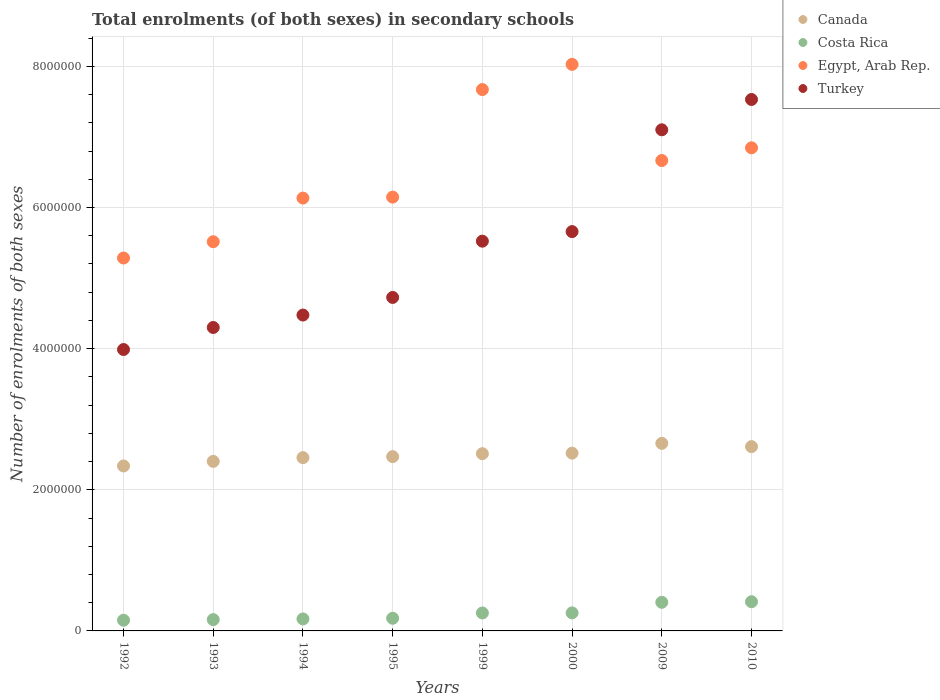How many different coloured dotlines are there?
Offer a terse response. 4. Is the number of dotlines equal to the number of legend labels?
Give a very brief answer. Yes. What is the number of enrolments in secondary schools in Costa Rica in 2000?
Provide a succinct answer. 2.56e+05. Across all years, what is the maximum number of enrolments in secondary schools in Canada?
Your response must be concise. 2.66e+06. Across all years, what is the minimum number of enrolments in secondary schools in Egypt, Arab Rep.?
Keep it short and to the point. 5.28e+06. What is the total number of enrolments in secondary schools in Costa Rica in the graph?
Offer a terse response. 1.99e+06. What is the difference between the number of enrolments in secondary schools in Canada in 1992 and that in 1994?
Give a very brief answer. -1.18e+05. What is the difference between the number of enrolments in secondary schools in Canada in 1992 and the number of enrolments in secondary schools in Egypt, Arab Rep. in 1994?
Give a very brief answer. -3.80e+06. What is the average number of enrolments in secondary schools in Costa Rica per year?
Provide a short and direct response. 2.49e+05. In the year 1999, what is the difference between the number of enrolments in secondary schools in Costa Rica and number of enrolments in secondary schools in Egypt, Arab Rep.?
Provide a succinct answer. -7.42e+06. What is the ratio of the number of enrolments in secondary schools in Egypt, Arab Rep. in 1993 to that in 1999?
Give a very brief answer. 0.72. Is the difference between the number of enrolments in secondary schools in Costa Rica in 1994 and 2000 greater than the difference between the number of enrolments in secondary schools in Egypt, Arab Rep. in 1994 and 2000?
Your response must be concise. Yes. What is the difference between the highest and the second highest number of enrolments in secondary schools in Turkey?
Make the answer very short. 4.30e+05. What is the difference between the highest and the lowest number of enrolments in secondary schools in Turkey?
Keep it short and to the point. 3.54e+06. In how many years, is the number of enrolments in secondary schools in Costa Rica greater than the average number of enrolments in secondary schools in Costa Rica taken over all years?
Ensure brevity in your answer.  4. Is it the case that in every year, the sum of the number of enrolments in secondary schools in Turkey and number of enrolments in secondary schools in Egypt, Arab Rep.  is greater than the number of enrolments in secondary schools in Costa Rica?
Offer a very short reply. Yes. Does the number of enrolments in secondary schools in Costa Rica monotonically increase over the years?
Provide a succinct answer. Yes. Is the number of enrolments in secondary schools in Canada strictly greater than the number of enrolments in secondary schools in Egypt, Arab Rep. over the years?
Give a very brief answer. No. Is the number of enrolments in secondary schools in Costa Rica strictly less than the number of enrolments in secondary schools in Turkey over the years?
Ensure brevity in your answer.  Yes. How many dotlines are there?
Your answer should be very brief. 4. Are the values on the major ticks of Y-axis written in scientific E-notation?
Ensure brevity in your answer.  No. Does the graph contain grids?
Give a very brief answer. Yes. Where does the legend appear in the graph?
Ensure brevity in your answer.  Top right. How many legend labels are there?
Provide a short and direct response. 4. What is the title of the graph?
Keep it short and to the point. Total enrolments (of both sexes) in secondary schools. What is the label or title of the Y-axis?
Your answer should be compact. Number of enrolments of both sexes. What is the Number of enrolments of both sexes in Canada in 1992?
Offer a very short reply. 2.34e+06. What is the Number of enrolments of both sexes of Costa Rica in 1992?
Give a very brief answer. 1.52e+05. What is the Number of enrolments of both sexes of Egypt, Arab Rep. in 1992?
Make the answer very short. 5.28e+06. What is the Number of enrolments of both sexes in Turkey in 1992?
Your response must be concise. 3.99e+06. What is the Number of enrolments of both sexes in Canada in 1993?
Make the answer very short. 2.40e+06. What is the Number of enrolments of both sexes in Costa Rica in 1993?
Make the answer very short. 1.60e+05. What is the Number of enrolments of both sexes of Egypt, Arab Rep. in 1993?
Give a very brief answer. 5.52e+06. What is the Number of enrolments of both sexes of Turkey in 1993?
Your response must be concise. 4.30e+06. What is the Number of enrolments of both sexes in Canada in 1994?
Provide a short and direct response. 2.46e+06. What is the Number of enrolments of both sexes of Costa Rica in 1994?
Make the answer very short. 1.70e+05. What is the Number of enrolments of both sexes of Egypt, Arab Rep. in 1994?
Offer a very short reply. 6.13e+06. What is the Number of enrolments of both sexes of Turkey in 1994?
Your answer should be compact. 4.48e+06. What is the Number of enrolments of both sexes in Canada in 1995?
Make the answer very short. 2.47e+06. What is the Number of enrolments of both sexes of Costa Rica in 1995?
Your answer should be compact. 1.79e+05. What is the Number of enrolments of both sexes of Egypt, Arab Rep. in 1995?
Provide a short and direct response. 6.15e+06. What is the Number of enrolments of both sexes of Turkey in 1995?
Offer a very short reply. 4.73e+06. What is the Number of enrolments of both sexes of Canada in 1999?
Provide a short and direct response. 2.51e+06. What is the Number of enrolments of both sexes in Costa Rica in 1999?
Provide a succinct answer. 2.55e+05. What is the Number of enrolments of both sexes in Egypt, Arab Rep. in 1999?
Your answer should be very brief. 7.67e+06. What is the Number of enrolments of both sexes in Turkey in 1999?
Provide a short and direct response. 5.52e+06. What is the Number of enrolments of both sexes in Canada in 2000?
Your answer should be compact. 2.52e+06. What is the Number of enrolments of both sexes of Costa Rica in 2000?
Offer a very short reply. 2.56e+05. What is the Number of enrolments of both sexes of Egypt, Arab Rep. in 2000?
Keep it short and to the point. 8.03e+06. What is the Number of enrolments of both sexes of Turkey in 2000?
Make the answer very short. 5.66e+06. What is the Number of enrolments of both sexes of Canada in 2009?
Your answer should be very brief. 2.66e+06. What is the Number of enrolments of both sexes in Costa Rica in 2009?
Offer a terse response. 4.06e+05. What is the Number of enrolments of both sexes of Egypt, Arab Rep. in 2009?
Keep it short and to the point. 6.67e+06. What is the Number of enrolments of both sexes in Turkey in 2009?
Provide a short and direct response. 7.10e+06. What is the Number of enrolments of both sexes in Canada in 2010?
Ensure brevity in your answer.  2.61e+06. What is the Number of enrolments of both sexes of Costa Rica in 2010?
Your answer should be very brief. 4.14e+05. What is the Number of enrolments of both sexes in Egypt, Arab Rep. in 2010?
Your response must be concise. 6.85e+06. What is the Number of enrolments of both sexes of Turkey in 2010?
Keep it short and to the point. 7.53e+06. Across all years, what is the maximum Number of enrolments of both sexes in Canada?
Ensure brevity in your answer.  2.66e+06. Across all years, what is the maximum Number of enrolments of both sexes of Costa Rica?
Your answer should be very brief. 4.14e+05. Across all years, what is the maximum Number of enrolments of both sexes of Egypt, Arab Rep.?
Offer a terse response. 8.03e+06. Across all years, what is the maximum Number of enrolments of both sexes of Turkey?
Provide a succinct answer. 7.53e+06. Across all years, what is the minimum Number of enrolments of both sexes in Canada?
Offer a very short reply. 2.34e+06. Across all years, what is the minimum Number of enrolments of both sexes in Costa Rica?
Offer a terse response. 1.52e+05. Across all years, what is the minimum Number of enrolments of both sexes of Egypt, Arab Rep.?
Offer a terse response. 5.28e+06. Across all years, what is the minimum Number of enrolments of both sexes in Turkey?
Offer a very short reply. 3.99e+06. What is the total Number of enrolments of both sexes in Canada in the graph?
Offer a terse response. 2.00e+07. What is the total Number of enrolments of both sexes of Costa Rica in the graph?
Your answer should be compact. 1.99e+06. What is the total Number of enrolments of both sexes in Egypt, Arab Rep. in the graph?
Make the answer very short. 5.23e+07. What is the total Number of enrolments of both sexes in Turkey in the graph?
Your answer should be compact. 4.33e+07. What is the difference between the Number of enrolments of both sexes of Canada in 1992 and that in 1993?
Make the answer very short. -6.50e+04. What is the difference between the Number of enrolments of both sexes of Costa Rica in 1992 and that in 1993?
Offer a terse response. -8778. What is the difference between the Number of enrolments of both sexes of Egypt, Arab Rep. in 1992 and that in 1993?
Provide a short and direct response. -2.31e+05. What is the difference between the Number of enrolments of both sexes in Turkey in 1992 and that in 1993?
Offer a terse response. -3.12e+05. What is the difference between the Number of enrolments of both sexes of Canada in 1992 and that in 1994?
Give a very brief answer. -1.18e+05. What is the difference between the Number of enrolments of both sexes of Costa Rica in 1992 and that in 1994?
Make the answer very short. -1.83e+04. What is the difference between the Number of enrolments of both sexes of Egypt, Arab Rep. in 1992 and that in 1994?
Give a very brief answer. -8.49e+05. What is the difference between the Number of enrolments of both sexes in Turkey in 1992 and that in 1994?
Provide a succinct answer. -4.89e+05. What is the difference between the Number of enrolments of both sexes in Canada in 1992 and that in 1995?
Your response must be concise. -1.32e+05. What is the difference between the Number of enrolments of both sexes in Costa Rica in 1992 and that in 1995?
Make the answer very short. -2.79e+04. What is the difference between the Number of enrolments of both sexes of Egypt, Arab Rep. in 1992 and that in 1995?
Ensure brevity in your answer.  -8.63e+05. What is the difference between the Number of enrolments of both sexes in Turkey in 1992 and that in 1995?
Your answer should be compact. -7.38e+05. What is the difference between the Number of enrolments of both sexes in Canada in 1992 and that in 1999?
Provide a short and direct response. -1.74e+05. What is the difference between the Number of enrolments of both sexes in Costa Rica in 1992 and that in 1999?
Your answer should be very brief. -1.03e+05. What is the difference between the Number of enrolments of both sexes of Egypt, Arab Rep. in 1992 and that in 1999?
Your response must be concise. -2.39e+06. What is the difference between the Number of enrolments of both sexes in Turkey in 1992 and that in 1999?
Your response must be concise. -1.54e+06. What is the difference between the Number of enrolments of both sexes in Canada in 1992 and that in 2000?
Offer a very short reply. -1.82e+05. What is the difference between the Number of enrolments of both sexes of Costa Rica in 1992 and that in 2000?
Your response must be concise. -1.04e+05. What is the difference between the Number of enrolments of both sexes of Egypt, Arab Rep. in 1992 and that in 2000?
Give a very brief answer. -2.74e+06. What is the difference between the Number of enrolments of both sexes of Turkey in 1992 and that in 2000?
Keep it short and to the point. -1.67e+06. What is the difference between the Number of enrolments of both sexes in Canada in 1992 and that in 2009?
Keep it short and to the point. -3.20e+05. What is the difference between the Number of enrolments of both sexes of Costa Rica in 1992 and that in 2009?
Your answer should be very brief. -2.54e+05. What is the difference between the Number of enrolments of both sexes in Egypt, Arab Rep. in 1992 and that in 2009?
Ensure brevity in your answer.  -1.38e+06. What is the difference between the Number of enrolments of both sexes of Turkey in 1992 and that in 2009?
Your answer should be compact. -3.11e+06. What is the difference between the Number of enrolments of both sexes of Canada in 1992 and that in 2010?
Make the answer very short. -2.74e+05. What is the difference between the Number of enrolments of both sexes in Costa Rica in 1992 and that in 2010?
Your answer should be very brief. -2.62e+05. What is the difference between the Number of enrolments of both sexes in Egypt, Arab Rep. in 1992 and that in 2010?
Keep it short and to the point. -1.56e+06. What is the difference between the Number of enrolments of both sexes in Turkey in 1992 and that in 2010?
Offer a very short reply. -3.54e+06. What is the difference between the Number of enrolments of both sexes in Canada in 1993 and that in 1994?
Your answer should be very brief. -5.29e+04. What is the difference between the Number of enrolments of both sexes in Costa Rica in 1993 and that in 1994?
Your answer should be compact. -9486. What is the difference between the Number of enrolments of both sexes in Egypt, Arab Rep. in 1993 and that in 1994?
Ensure brevity in your answer.  -6.18e+05. What is the difference between the Number of enrolments of both sexes in Turkey in 1993 and that in 1994?
Make the answer very short. -1.76e+05. What is the difference between the Number of enrolments of both sexes of Canada in 1993 and that in 1995?
Your response must be concise. -6.70e+04. What is the difference between the Number of enrolments of both sexes of Costa Rica in 1993 and that in 1995?
Keep it short and to the point. -1.91e+04. What is the difference between the Number of enrolments of both sexes in Egypt, Arab Rep. in 1993 and that in 1995?
Ensure brevity in your answer.  -6.32e+05. What is the difference between the Number of enrolments of both sexes in Turkey in 1993 and that in 1995?
Your answer should be very brief. -4.26e+05. What is the difference between the Number of enrolments of both sexes in Canada in 1993 and that in 1999?
Make the answer very short. -1.09e+05. What is the difference between the Number of enrolments of both sexes in Costa Rica in 1993 and that in 1999?
Your answer should be very brief. -9.43e+04. What is the difference between the Number of enrolments of both sexes of Egypt, Arab Rep. in 1993 and that in 1999?
Give a very brief answer. -2.16e+06. What is the difference between the Number of enrolments of both sexes in Turkey in 1993 and that in 1999?
Your response must be concise. -1.22e+06. What is the difference between the Number of enrolments of both sexes of Canada in 1993 and that in 2000?
Make the answer very short. -1.17e+05. What is the difference between the Number of enrolments of both sexes in Costa Rica in 1993 and that in 2000?
Ensure brevity in your answer.  -9.54e+04. What is the difference between the Number of enrolments of both sexes in Egypt, Arab Rep. in 1993 and that in 2000?
Your answer should be very brief. -2.51e+06. What is the difference between the Number of enrolments of both sexes in Turkey in 1993 and that in 2000?
Provide a succinct answer. -1.36e+06. What is the difference between the Number of enrolments of both sexes of Canada in 1993 and that in 2009?
Provide a succinct answer. -2.55e+05. What is the difference between the Number of enrolments of both sexes of Costa Rica in 1993 and that in 2009?
Offer a very short reply. -2.45e+05. What is the difference between the Number of enrolments of both sexes in Egypt, Arab Rep. in 1993 and that in 2009?
Your answer should be very brief. -1.15e+06. What is the difference between the Number of enrolments of both sexes of Turkey in 1993 and that in 2009?
Provide a short and direct response. -2.80e+06. What is the difference between the Number of enrolments of both sexes of Canada in 1993 and that in 2010?
Make the answer very short. -2.09e+05. What is the difference between the Number of enrolments of both sexes in Costa Rica in 1993 and that in 2010?
Make the answer very short. -2.53e+05. What is the difference between the Number of enrolments of both sexes in Egypt, Arab Rep. in 1993 and that in 2010?
Your response must be concise. -1.33e+06. What is the difference between the Number of enrolments of both sexes of Turkey in 1993 and that in 2010?
Offer a terse response. -3.23e+06. What is the difference between the Number of enrolments of both sexes in Canada in 1994 and that in 1995?
Your answer should be compact. -1.41e+04. What is the difference between the Number of enrolments of both sexes of Costa Rica in 1994 and that in 1995?
Ensure brevity in your answer.  -9663. What is the difference between the Number of enrolments of both sexes of Egypt, Arab Rep. in 1994 and that in 1995?
Your answer should be very brief. -1.40e+04. What is the difference between the Number of enrolments of both sexes in Turkey in 1994 and that in 1995?
Offer a terse response. -2.49e+05. What is the difference between the Number of enrolments of both sexes of Canada in 1994 and that in 1999?
Provide a short and direct response. -5.61e+04. What is the difference between the Number of enrolments of both sexes of Costa Rica in 1994 and that in 1999?
Ensure brevity in your answer.  -8.48e+04. What is the difference between the Number of enrolments of both sexes in Egypt, Arab Rep. in 1994 and that in 1999?
Offer a terse response. -1.54e+06. What is the difference between the Number of enrolments of both sexes of Turkey in 1994 and that in 1999?
Your answer should be very brief. -1.05e+06. What is the difference between the Number of enrolments of both sexes of Canada in 1994 and that in 2000?
Your answer should be compact. -6.37e+04. What is the difference between the Number of enrolments of both sexes in Costa Rica in 1994 and that in 2000?
Make the answer very short. -8.59e+04. What is the difference between the Number of enrolments of both sexes of Egypt, Arab Rep. in 1994 and that in 2000?
Your response must be concise. -1.89e+06. What is the difference between the Number of enrolments of both sexes of Turkey in 1994 and that in 2000?
Your answer should be very brief. -1.18e+06. What is the difference between the Number of enrolments of both sexes in Canada in 1994 and that in 2009?
Your answer should be compact. -2.03e+05. What is the difference between the Number of enrolments of both sexes of Costa Rica in 1994 and that in 2009?
Provide a succinct answer. -2.36e+05. What is the difference between the Number of enrolments of both sexes in Egypt, Arab Rep. in 1994 and that in 2009?
Keep it short and to the point. -5.32e+05. What is the difference between the Number of enrolments of both sexes of Turkey in 1994 and that in 2009?
Your answer should be very brief. -2.62e+06. What is the difference between the Number of enrolments of both sexes in Canada in 1994 and that in 2010?
Your response must be concise. -1.56e+05. What is the difference between the Number of enrolments of both sexes in Costa Rica in 1994 and that in 2010?
Your response must be concise. -2.44e+05. What is the difference between the Number of enrolments of both sexes of Egypt, Arab Rep. in 1994 and that in 2010?
Ensure brevity in your answer.  -7.12e+05. What is the difference between the Number of enrolments of both sexes in Turkey in 1994 and that in 2010?
Provide a succinct answer. -3.05e+06. What is the difference between the Number of enrolments of both sexes of Canada in 1995 and that in 1999?
Your answer should be compact. -4.20e+04. What is the difference between the Number of enrolments of both sexes in Costa Rica in 1995 and that in 1999?
Provide a succinct answer. -7.52e+04. What is the difference between the Number of enrolments of both sexes of Egypt, Arab Rep. in 1995 and that in 1999?
Your answer should be very brief. -1.52e+06. What is the difference between the Number of enrolments of both sexes in Turkey in 1995 and that in 1999?
Provide a short and direct response. -7.97e+05. What is the difference between the Number of enrolments of both sexes of Canada in 1995 and that in 2000?
Provide a short and direct response. -4.95e+04. What is the difference between the Number of enrolments of both sexes in Costa Rica in 1995 and that in 2000?
Provide a short and direct response. -7.62e+04. What is the difference between the Number of enrolments of both sexes of Egypt, Arab Rep. in 1995 and that in 2000?
Offer a terse response. -1.88e+06. What is the difference between the Number of enrolments of both sexes of Turkey in 1995 and that in 2000?
Offer a terse response. -9.33e+05. What is the difference between the Number of enrolments of both sexes of Canada in 1995 and that in 2009?
Your answer should be very brief. -1.88e+05. What is the difference between the Number of enrolments of both sexes in Costa Rica in 1995 and that in 2009?
Give a very brief answer. -2.26e+05. What is the difference between the Number of enrolments of both sexes of Egypt, Arab Rep. in 1995 and that in 2009?
Provide a short and direct response. -5.19e+05. What is the difference between the Number of enrolments of both sexes in Turkey in 1995 and that in 2009?
Your response must be concise. -2.38e+06. What is the difference between the Number of enrolments of both sexes of Canada in 1995 and that in 2010?
Offer a very short reply. -1.42e+05. What is the difference between the Number of enrolments of both sexes in Costa Rica in 1995 and that in 2010?
Your answer should be compact. -2.34e+05. What is the difference between the Number of enrolments of both sexes in Egypt, Arab Rep. in 1995 and that in 2010?
Offer a very short reply. -6.98e+05. What is the difference between the Number of enrolments of both sexes in Turkey in 1995 and that in 2010?
Offer a very short reply. -2.81e+06. What is the difference between the Number of enrolments of both sexes of Canada in 1999 and that in 2000?
Your answer should be very brief. -7563. What is the difference between the Number of enrolments of both sexes in Costa Rica in 1999 and that in 2000?
Give a very brief answer. -1046. What is the difference between the Number of enrolments of both sexes of Egypt, Arab Rep. in 1999 and that in 2000?
Your response must be concise. -3.57e+05. What is the difference between the Number of enrolments of both sexes of Turkey in 1999 and that in 2000?
Your answer should be very brief. -1.35e+05. What is the difference between the Number of enrolments of both sexes of Canada in 1999 and that in 2009?
Make the answer very short. -1.46e+05. What is the difference between the Number of enrolments of both sexes in Costa Rica in 1999 and that in 2009?
Keep it short and to the point. -1.51e+05. What is the difference between the Number of enrolments of both sexes of Egypt, Arab Rep. in 1999 and that in 2009?
Your answer should be very brief. 1.01e+06. What is the difference between the Number of enrolments of both sexes of Turkey in 1999 and that in 2009?
Keep it short and to the point. -1.58e+06. What is the difference between the Number of enrolments of both sexes of Canada in 1999 and that in 2010?
Offer a terse response. -1.00e+05. What is the difference between the Number of enrolments of both sexes of Costa Rica in 1999 and that in 2010?
Ensure brevity in your answer.  -1.59e+05. What is the difference between the Number of enrolments of both sexes in Egypt, Arab Rep. in 1999 and that in 2010?
Ensure brevity in your answer.  8.25e+05. What is the difference between the Number of enrolments of both sexes of Turkey in 1999 and that in 2010?
Provide a short and direct response. -2.01e+06. What is the difference between the Number of enrolments of both sexes of Canada in 2000 and that in 2009?
Offer a very short reply. -1.39e+05. What is the difference between the Number of enrolments of both sexes in Costa Rica in 2000 and that in 2009?
Give a very brief answer. -1.50e+05. What is the difference between the Number of enrolments of both sexes of Egypt, Arab Rep. in 2000 and that in 2009?
Your answer should be compact. 1.36e+06. What is the difference between the Number of enrolments of both sexes of Turkey in 2000 and that in 2009?
Keep it short and to the point. -1.44e+06. What is the difference between the Number of enrolments of both sexes of Canada in 2000 and that in 2010?
Your answer should be compact. -9.25e+04. What is the difference between the Number of enrolments of both sexes of Costa Rica in 2000 and that in 2010?
Make the answer very short. -1.58e+05. What is the difference between the Number of enrolments of both sexes in Egypt, Arab Rep. in 2000 and that in 2010?
Offer a terse response. 1.18e+06. What is the difference between the Number of enrolments of both sexes of Turkey in 2000 and that in 2010?
Your response must be concise. -1.87e+06. What is the difference between the Number of enrolments of both sexes in Canada in 2009 and that in 2010?
Your answer should be very brief. 4.63e+04. What is the difference between the Number of enrolments of both sexes of Costa Rica in 2009 and that in 2010?
Ensure brevity in your answer.  -8102. What is the difference between the Number of enrolments of both sexes of Egypt, Arab Rep. in 2009 and that in 2010?
Provide a short and direct response. -1.80e+05. What is the difference between the Number of enrolments of both sexes in Turkey in 2009 and that in 2010?
Offer a terse response. -4.30e+05. What is the difference between the Number of enrolments of both sexes of Canada in 1992 and the Number of enrolments of both sexes of Costa Rica in 1993?
Ensure brevity in your answer.  2.18e+06. What is the difference between the Number of enrolments of both sexes of Canada in 1992 and the Number of enrolments of both sexes of Egypt, Arab Rep. in 1993?
Provide a succinct answer. -3.18e+06. What is the difference between the Number of enrolments of both sexes of Canada in 1992 and the Number of enrolments of both sexes of Turkey in 1993?
Give a very brief answer. -1.96e+06. What is the difference between the Number of enrolments of both sexes of Costa Rica in 1992 and the Number of enrolments of both sexes of Egypt, Arab Rep. in 1993?
Offer a terse response. -5.36e+06. What is the difference between the Number of enrolments of both sexes in Costa Rica in 1992 and the Number of enrolments of both sexes in Turkey in 1993?
Keep it short and to the point. -4.15e+06. What is the difference between the Number of enrolments of both sexes in Egypt, Arab Rep. in 1992 and the Number of enrolments of both sexes in Turkey in 1993?
Your answer should be compact. 9.84e+05. What is the difference between the Number of enrolments of both sexes of Canada in 1992 and the Number of enrolments of both sexes of Costa Rica in 1994?
Your answer should be very brief. 2.17e+06. What is the difference between the Number of enrolments of both sexes in Canada in 1992 and the Number of enrolments of both sexes in Egypt, Arab Rep. in 1994?
Your answer should be compact. -3.80e+06. What is the difference between the Number of enrolments of both sexes in Canada in 1992 and the Number of enrolments of both sexes in Turkey in 1994?
Provide a short and direct response. -2.14e+06. What is the difference between the Number of enrolments of both sexes of Costa Rica in 1992 and the Number of enrolments of both sexes of Egypt, Arab Rep. in 1994?
Provide a short and direct response. -5.98e+06. What is the difference between the Number of enrolments of both sexes of Costa Rica in 1992 and the Number of enrolments of both sexes of Turkey in 1994?
Offer a very short reply. -4.32e+06. What is the difference between the Number of enrolments of both sexes in Egypt, Arab Rep. in 1992 and the Number of enrolments of both sexes in Turkey in 1994?
Offer a very short reply. 8.08e+05. What is the difference between the Number of enrolments of both sexes in Canada in 1992 and the Number of enrolments of both sexes in Costa Rica in 1995?
Your answer should be compact. 2.16e+06. What is the difference between the Number of enrolments of both sexes of Canada in 1992 and the Number of enrolments of both sexes of Egypt, Arab Rep. in 1995?
Provide a short and direct response. -3.81e+06. What is the difference between the Number of enrolments of both sexes in Canada in 1992 and the Number of enrolments of both sexes in Turkey in 1995?
Your answer should be very brief. -2.39e+06. What is the difference between the Number of enrolments of both sexes of Costa Rica in 1992 and the Number of enrolments of both sexes of Egypt, Arab Rep. in 1995?
Offer a very short reply. -6.00e+06. What is the difference between the Number of enrolments of both sexes of Costa Rica in 1992 and the Number of enrolments of both sexes of Turkey in 1995?
Provide a succinct answer. -4.57e+06. What is the difference between the Number of enrolments of both sexes in Egypt, Arab Rep. in 1992 and the Number of enrolments of both sexes in Turkey in 1995?
Offer a terse response. 5.59e+05. What is the difference between the Number of enrolments of both sexes of Canada in 1992 and the Number of enrolments of both sexes of Costa Rica in 1999?
Provide a short and direct response. 2.08e+06. What is the difference between the Number of enrolments of both sexes in Canada in 1992 and the Number of enrolments of both sexes in Egypt, Arab Rep. in 1999?
Ensure brevity in your answer.  -5.33e+06. What is the difference between the Number of enrolments of both sexes in Canada in 1992 and the Number of enrolments of both sexes in Turkey in 1999?
Keep it short and to the point. -3.19e+06. What is the difference between the Number of enrolments of both sexes in Costa Rica in 1992 and the Number of enrolments of both sexes in Egypt, Arab Rep. in 1999?
Your answer should be very brief. -7.52e+06. What is the difference between the Number of enrolments of both sexes of Costa Rica in 1992 and the Number of enrolments of both sexes of Turkey in 1999?
Keep it short and to the point. -5.37e+06. What is the difference between the Number of enrolments of both sexes in Egypt, Arab Rep. in 1992 and the Number of enrolments of both sexes in Turkey in 1999?
Your answer should be very brief. -2.39e+05. What is the difference between the Number of enrolments of both sexes of Canada in 1992 and the Number of enrolments of both sexes of Costa Rica in 2000?
Your answer should be compact. 2.08e+06. What is the difference between the Number of enrolments of both sexes of Canada in 1992 and the Number of enrolments of both sexes of Egypt, Arab Rep. in 2000?
Keep it short and to the point. -5.69e+06. What is the difference between the Number of enrolments of both sexes in Canada in 1992 and the Number of enrolments of both sexes in Turkey in 2000?
Ensure brevity in your answer.  -3.32e+06. What is the difference between the Number of enrolments of both sexes of Costa Rica in 1992 and the Number of enrolments of both sexes of Egypt, Arab Rep. in 2000?
Make the answer very short. -7.88e+06. What is the difference between the Number of enrolments of both sexes in Costa Rica in 1992 and the Number of enrolments of both sexes in Turkey in 2000?
Make the answer very short. -5.51e+06. What is the difference between the Number of enrolments of both sexes in Egypt, Arab Rep. in 1992 and the Number of enrolments of both sexes in Turkey in 2000?
Your answer should be compact. -3.74e+05. What is the difference between the Number of enrolments of both sexes in Canada in 1992 and the Number of enrolments of both sexes in Costa Rica in 2009?
Offer a terse response. 1.93e+06. What is the difference between the Number of enrolments of both sexes in Canada in 1992 and the Number of enrolments of both sexes in Egypt, Arab Rep. in 2009?
Your answer should be very brief. -4.33e+06. What is the difference between the Number of enrolments of both sexes in Canada in 1992 and the Number of enrolments of both sexes in Turkey in 2009?
Provide a short and direct response. -4.76e+06. What is the difference between the Number of enrolments of both sexes in Costa Rica in 1992 and the Number of enrolments of both sexes in Egypt, Arab Rep. in 2009?
Keep it short and to the point. -6.51e+06. What is the difference between the Number of enrolments of both sexes in Costa Rica in 1992 and the Number of enrolments of both sexes in Turkey in 2009?
Make the answer very short. -6.95e+06. What is the difference between the Number of enrolments of both sexes of Egypt, Arab Rep. in 1992 and the Number of enrolments of both sexes of Turkey in 2009?
Ensure brevity in your answer.  -1.82e+06. What is the difference between the Number of enrolments of both sexes of Canada in 1992 and the Number of enrolments of both sexes of Costa Rica in 2010?
Provide a succinct answer. 1.92e+06. What is the difference between the Number of enrolments of both sexes in Canada in 1992 and the Number of enrolments of both sexes in Egypt, Arab Rep. in 2010?
Offer a very short reply. -4.51e+06. What is the difference between the Number of enrolments of both sexes of Canada in 1992 and the Number of enrolments of both sexes of Turkey in 2010?
Your response must be concise. -5.19e+06. What is the difference between the Number of enrolments of both sexes of Costa Rica in 1992 and the Number of enrolments of both sexes of Egypt, Arab Rep. in 2010?
Offer a very short reply. -6.69e+06. What is the difference between the Number of enrolments of both sexes of Costa Rica in 1992 and the Number of enrolments of both sexes of Turkey in 2010?
Offer a very short reply. -7.38e+06. What is the difference between the Number of enrolments of both sexes in Egypt, Arab Rep. in 1992 and the Number of enrolments of both sexes in Turkey in 2010?
Provide a succinct answer. -2.25e+06. What is the difference between the Number of enrolments of both sexes in Canada in 1993 and the Number of enrolments of both sexes in Costa Rica in 1994?
Offer a very short reply. 2.23e+06. What is the difference between the Number of enrolments of both sexes in Canada in 1993 and the Number of enrolments of both sexes in Egypt, Arab Rep. in 1994?
Make the answer very short. -3.73e+06. What is the difference between the Number of enrolments of both sexes of Canada in 1993 and the Number of enrolments of both sexes of Turkey in 1994?
Offer a very short reply. -2.07e+06. What is the difference between the Number of enrolments of both sexes of Costa Rica in 1993 and the Number of enrolments of both sexes of Egypt, Arab Rep. in 1994?
Ensure brevity in your answer.  -5.97e+06. What is the difference between the Number of enrolments of both sexes in Costa Rica in 1993 and the Number of enrolments of both sexes in Turkey in 1994?
Your response must be concise. -4.32e+06. What is the difference between the Number of enrolments of both sexes of Egypt, Arab Rep. in 1993 and the Number of enrolments of both sexes of Turkey in 1994?
Make the answer very short. 1.04e+06. What is the difference between the Number of enrolments of both sexes of Canada in 1993 and the Number of enrolments of both sexes of Costa Rica in 1995?
Provide a succinct answer. 2.22e+06. What is the difference between the Number of enrolments of both sexes in Canada in 1993 and the Number of enrolments of both sexes in Egypt, Arab Rep. in 1995?
Give a very brief answer. -3.74e+06. What is the difference between the Number of enrolments of both sexes in Canada in 1993 and the Number of enrolments of both sexes in Turkey in 1995?
Provide a short and direct response. -2.32e+06. What is the difference between the Number of enrolments of both sexes of Costa Rica in 1993 and the Number of enrolments of both sexes of Egypt, Arab Rep. in 1995?
Provide a succinct answer. -5.99e+06. What is the difference between the Number of enrolments of both sexes of Costa Rica in 1993 and the Number of enrolments of both sexes of Turkey in 1995?
Provide a short and direct response. -4.57e+06. What is the difference between the Number of enrolments of both sexes of Egypt, Arab Rep. in 1993 and the Number of enrolments of both sexes of Turkey in 1995?
Provide a succinct answer. 7.90e+05. What is the difference between the Number of enrolments of both sexes of Canada in 1993 and the Number of enrolments of both sexes of Costa Rica in 1999?
Offer a very short reply. 2.15e+06. What is the difference between the Number of enrolments of both sexes in Canada in 1993 and the Number of enrolments of both sexes in Egypt, Arab Rep. in 1999?
Give a very brief answer. -5.27e+06. What is the difference between the Number of enrolments of both sexes in Canada in 1993 and the Number of enrolments of both sexes in Turkey in 1999?
Offer a terse response. -3.12e+06. What is the difference between the Number of enrolments of both sexes in Costa Rica in 1993 and the Number of enrolments of both sexes in Egypt, Arab Rep. in 1999?
Offer a terse response. -7.51e+06. What is the difference between the Number of enrolments of both sexes in Costa Rica in 1993 and the Number of enrolments of both sexes in Turkey in 1999?
Provide a succinct answer. -5.36e+06. What is the difference between the Number of enrolments of both sexes in Egypt, Arab Rep. in 1993 and the Number of enrolments of both sexes in Turkey in 1999?
Provide a succinct answer. -7844. What is the difference between the Number of enrolments of both sexes of Canada in 1993 and the Number of enrolments of both sexes of Costa Rica in 2000?
Make the answer very short. 2.15e+06. What is the difference between the Number of enrolments of both sexes in Canada in 1993 and the Number of enrolments of both sexes in Egypt, Arab Rep. in 2000?
Your response must be concise. -5.63e+06. What is the difference between the Number of enrolments of both sexes in Canada in 1993 and the Number of enrolments of both sexes in Turkey in 2000?
Provide a succinct answer. -3.26e+06. What is the difference between the Number of enrolments of both sexes in Costa Rica in 1993 and the Number of enrolments of both sexes in Egypt, Arab Rep. in 2000?
Offer a very short reply. -7.87e+06. What is the difference between the Number of enrolments of both sexes in Costa Rica in 1993 and the Number of enrolments of both sexes in Turkey in 2000?
Offer a terse response. -5.50e+06. What is the difference between the Number of enrolments of both sexes of Egypt, Arab Rep. in 1993 and the Number of enrolments of both sexes of Turkey in 2000?
Keep it short and to the point. -1.43e+05. What is the difference between the Number of enrolments of both sexes in Canada in 1993 and the Number of enrolments of both sexes in Costa Rica in 2009?
Your answer should be very brief. 2.00e+06. What is the difference between the Number of enrolments of both sexes of Canada in 1993 and the Number of enrolments of both sexes of Egypt, Arab Rep. in 2009?
Your answer should be compact. -4.26e+06. What is the difference between the Number of enrolments of both sexes in Canada in 1993 and the Number of enrolments of both sexes in Turkey in 2009?
Give a very brief answer. -4.70e+06. What is the difference between the Number of enrolments of both sexes in Costa Rica in 1993 and the Number of enrolments of both sexes in Egypt, Arab Rep. in 2009?
Provide a succinct answer. -6.51e+06. What is the difference between the Number of enrolments of both sexes in Costa Rica in 1993 and the Number of enrolments of both sexes in Turkey in 2009?
Your answer should be compact. -6.94e+06. What is the difference between the Number of enrolments of both sexes of Egypt, Arab Rep. in 1993 and the Number of enrolments of both sexes of Turkey in 2009?
Provide a succinct answer. -1.59e+06. What is the difference between the Number of enrolments of both sexes in Canada in 1993 and the Number of enrolments of both sexes in Costa Rica in 2010?
Offer a very short reply. 1.99e+06. What is the difference between the Number of enrolments of both sexes of Canada in 1993 and the Number of enrolments of both sexes of Egypt, Arab Rep. in 2010?
Provide a succinct answer. -4.44e+06. What is the difference between the Number of enrolments of both sexes of Canada in 1993 and the Number of enrolments of both sexes of Turkey in 2010?
Keep it short and to the point. -5.13e+06. What is the difference between the Number of enrolments of both sexes of Costa Rica in 1993 and the Number of enrolments of both sexes of Egypt, Arab Rep. in 2010?
Make the answer very short. -6.69e+06. What is the difference between the Number of enrolments of both sexes in Costa Rica in 1993 and the Number of enrolments of both sexes in Turkey in 2010?
Offer a very short reply. -7.37e+06. What is the difference between the Number of enrolments of both sexes of Egypt, Arab Rep. in 1993 and the Number of enrolments of both sexes of Turkey in 2010?
Offer a very short reply. -2.02e+06. What is the difference between the Number of enrolments of both sexes of Canada in 1994 and the Number of enrolments of both sexes of Costa Rica in 1995?
Provide a succinct answer. 2.28e+06. What is the difference between the Number of enrolments of both sexes in Canada in 1994 and the Number of enrolments of both sexes in Egypt, Arab Rep. in 1995?
Provide a short and direct response. -3.69e+06. What is the difference between the Number of enrolments of both sexes of Canada in 1994 and the Number of enrolments of both sexes of Turkey in 1995?
Keep it short and to the point. -2.27e+06. What is the difference between the Number of enrolments of both sexes of Costa Rica in 1994 and the Number of enrolments of both sexes of Egypt, Arab Rep. in 1995?
Offer a very short reply. -5.98e+06. What is the difference between the Number of enrolments of both sexes of Costa Rica in 1994 and the Number of enrolments of both sexes of Turkey in 1995?
Offer a terse response. -4.56e+06. What is the difference between the Number of enrolments of both sexes of Egypt, Arab Rep. in 1994 and the Number of enrolments of both sexes of Turkey in 1995?
Your answer should be compact. 1.41e+06. What is the difference between the Number of enrolments of both sexes of Canada in 1994 and the Number of enrolments of both sexes of Costa Rica in 1999?
Provide a succinct answer. 2.20e+06. What is the difference between the Number of enrolments of both sexes in Canada in 1994 and the Number of enrolments of both sexes in Egypt, Arab Rep. in 1999?
Your answer should be very brief. -5.22e+06. What is the difference between the Number of enrolments of both sexes in Canada in 1994 and the Number of enrolments of both sexes in Turkey in 1999?
Provide a short and direct response. -3.07e+06. What is the difference between the Number of enrolments of both sexes in Costa Rica in 1994 and the Number of enrolments of both sexes in Egypt, Arab Rep. in 1999?
Your answer should be compact. -7.50e+06. What is the difference between the Number of enrolments of both sexes in Costa Rica in 1994 and the Number of enrolments of both sexes in Turkey in 1999?
Keep it short and to the point. -5.35e+06. What is the difference between the Number of enrolments of both sexes in Egypt, Arab Rep. in 1994 and the Number of enrolments of both sexes in Turkey in 1999?
Offer a terse response. 6.10e+05. What is the difference between the Number of enrolments of both sexes of Canada in 1994 and the Number of enrolments of both sexes of Costa Rica in 2000?
Your answer should be very brief. 2.20e+06. What is the difference between the Number of enrolments of both sexes in Canada in 1994 and the Number of enrolments of both sexes in Egypt, Arab Rep. in 2000?
Your response must be concise. -5.57e+06. What is the difference between the Number of enrolments of both sexes of Canada in 1994 and the Number of enrolments of both sexes of Turkey in 2000?
Your answer should be very brief. -3.20e+06. What is the difference between the Number of enrolments of both sexes of Costa Rica in 1994 and the Number of enrolments of both sexes of Egypt, Arab Rep. in 2000?
Offer a very short reply. -7.86e+06. What is the difference between the Number of enrolments of both sexes in Costa Rica in 1994 and the Number of enrolments of both sexes in Turkey in 2000?
Your answer should be very brief. -5.49e+06. What is the difference between the Number of enrolments of both sexes of Egypt, Arab Rep. in 1994 and the Number of enrolments of both sexes of Turkey in 2000?
Give a very brief answer. 4.75e+05. What is the difference between the Number of enrolments of both sexes of Canada in 1994 and the Number of enrolments of both sexes of Costa Rica in 2009?
Offer a very short reply. 2.05e+06. What is the difference between the Number of enrolments of both sexes of Canada in 1994 and the Number of enrolments of both sexes of Egypt, Arab Rep. in 2009?
Your response must be concise. -4.21e+06. What is the difference between the Number of enrolments of both sexes in Canada in 1994 and the Number of enrolments of both sexes in Turkey in 2009?
Give a very brief answer. -4.65e+06. What is the difference between the Number of enrolments of both sexes of Costa Rica in 1994 and the Number of enrolments of both sexes of Egypt, Arab Rep. in 2009?
Provide a succinct answer. -6.50e+06. What is the difference between the Number of enrolments of both sexes in Costa Rica in 1994 and the Number of enrolments of both sexes in Turkey in 2009?
Offer a terse response. -6.93e+06. What is the difference between the Number of enrolments of both sexes in Egypt, Arab Rep. in 1994 and the Number of enrolments of both sexes in Turkey in 2009?
Offer a very short reply. -9.68e+05. What is the difference between the Number of enrolments of both sexes in Canada in 1994 and the Number of enrolments of both sexes in Costa Rica in 2010?
Provide a short and direct response. 2.04e+06. What is the difference between the Number of enrolments of both sexes in Canada in 1994 and the Number of enrolments of both sexes in Egypt, Arab Rep. in 2010?
Offer a very short reply. -4.39e+06. What is the difference between the Number of enrolments of both sexes of Canada in 1994 and the Number of enrolments of both sexes of Turkey in 2010?
Give a very brief answer. -5.08e+06. What is the difference between the Number of enrolments of both sexes in Costa Rica in 1994 and the Number of enrolments of both sexes in Egypt, Arab Rep. in 2010?
Ensure brevity in your answer.  -6.68e+06. What is the difference between the Number of enrolments of both sexes of Costa Rica in 1994 and the Number of enrolments of both sexes of Turkey in 2010?
Offer a terse response. -7.36e+06. What is the difference between the Number of enrolments of both sexes in Egypt, Arab Rep. in 1994 and the Number of enrolments of both sexes in Turkey in 2010?
Provide a short and direct response. -1.40e+06. What is the difference between the Number of enrolments of both sexes in Canada in 1995 and the Number of enrolments of both sexes in Costa Rica in 1999?
Offer a terse response. 2.21e+06. What is the difference between the Number of enrolments of both sexes in Canada in 1995 and the Number of enrolments of both sexes in Egypt, Arab Rep. in 1999?
Your answer should be very brief. -5.20e+06. What is the difference between the Number of enrolments of both sexes in Canada in 1995 and the Number of enrolments of both sexes in Turkey in 1999?
Your answer should be compact. -3.05e+06. What is the difference between the Number of enrolments of both sexes of Costa Rica in 1995 and the Number of enrolments of both sexes of Egypt, Arab Rep. in 1999?
Offer a terse response. -7.49e+06. What is the difference between the Number of enrolments of both sexes of Costa Rica in 1995 and the Number of enrolments of both sexes of Turkey in 1999?
Keep it short and to the point. -5.34e+06. What is the difference between the Number of enrolments of both sexes of Egypt, Arab Rep. in 1995 and the Number of enrolments of both sexes of Turkey in 1999?
Give a very brief answer. 6.24e+05. What is the difference between the Number of enrolments of both sexes in Canada in 1995 and the Number of enrolments of both sexes in Costa Rica in 2000?
Make the answer very short. 2.21e+06. What is the difference between the Number of enrolments of both sexes of Canada in 1995 and the Number of enrolments of both sexes of Egypt, Arab Rep. in 2000?
Provide a short and direct response. -5.56e+06. What is the difference between the Number of enrolments of both sexes of Canada in 1995 and the Number of enrolments of both sexes of Turkey in 2000?
Your answer should be very brief. -3.19e+06. What is the difference between the Number of enrolments of both sexes in Costa Rica in 1995 and the Number of enrolments of both sexes in Egypt, Arab Rep. in 2000?
Your response must be concise. -7.85e+06. What is the difference between the Number of enrolments of both sexes in Costa Rica in 1995 and the Number of enrolments of both sexes in Turkey in 2000?
Your response must be concise. -5.48e+06. What is the difference between the Number of enrolments of both sexes in Egypt, Arab Rep. in 1995 and the Number of enrolments of both sexes in Turkey in 2000?
Your response must be concise. 4.89e+05. What is the difference between the Number of enrolments of both sexes in Canada in 1995 and the Number of enrolments of both sexes in Costa Rica in 2009?
Make the answer very short. 2.06e+06. What is the difference between the Number of enrolments of both sexes in Canada in 1995 and the Number of enrolments of both sexes in Egypt, Arab Rep. in 2009?
Provide a short and direct response. -4.20e+06. What is the difference between the Number of enrolments of both sexes in Canada in 1995 and the Number of enrolments of both sexes in Turkey in 2009?
Provide a short and direct response. -4.63e+06. What is the difference between the Number of enrolments of both sexes of Costa Rica in 1995 and the Number of enrolments of both sexes of Egypt, Arab Rep. in 2009?
Your answer should be compact. -6.49e+06. What is the difference between the Number of enrolments of both sexes in Costa Rica in 1995 and the Number of enrolments of both sexes in Turkey in 2009?
Keep it short and to the point. -6.92e+06. What is the difference between the Number of enrolments of both sexes of Egypt, Arab Rep. in 1995 and the Number of enrolments of both sexes of Turkey in 2009?
Offer a very short reply. -9.54e+05. What is the difference between the Number of enrolments of both sexes of Canada in 1995 and the Number of enrolments of both sexes of Costa Rica in 2010?
Keep it short and to the point. 2.06e+06. What is the difference between the Number of enrolments of both sexes in Canada in 1995 and the Number of enrolments of both sexes in Egypt, Arab Rep. in 2010?
Provide a succinct answer. -4.38e+06. What is the difference between the Number of enrolments of both sexes in Canada in 1995 and the Number of enrolments of both sexes in Turkey in 2010?
Make the answer very short. -5.06e+06. What is the difference between the Number of enrolments of both sexes of Costa Rica in 1995 and the Number of enrolments of both sexes of Egypt, Arab Rep. in 2010?
Provide a short and direct response. -6.67e+06. What is the difference between the Number of enrolments of both sexes in Costa Rica in 1995 and the Number of enrolments of both sexes in Turkey in 2010?
Offer a very short reply. -7.35e+06. What is the difference between the Number of enrolments of both sexes of Egypt, Arab Rep. in 1995 and the Number of enrolments of both sexes of Turkey in 2010?
Provide a short and direct response. -1.38e+06. What is the difference between the Number of enrolments of both sexes in Canada in 1999 and the Number of enrolments of both sexes in Costa Rica in 2000?
Make the answer very short. 2.26e+06. What is the difference between the Number of enrolments of both sexes in Canada in 1999 and the Number of enrolments of both sexes in Egypt, Arab Rep. in 2000?
Make the answer very short. -5.52e+06. What is the difference between the Number of enrolments of both sexes of Canada in 1999 and the Number of enrolments of both sexes of Turkey in 2000?
Ensure brevity in your answer.  -3.15e+06. What is the difference between the Number of enrolments of both sexes of Costa Rica in 1999 and the Number of enrolments of both sexes of Egypt, Arab Rep. in 2000?
Make the answer very short. -7.77e+06. What is the difference between the Number of enrolments of both sexes of Costa Rica in 1999 and the Number of enrolments of both sexes of Turkey in 2000?
Ensure brevity in your answer.  -5.40e+06. What is the difference between the Number of enrolments of both sexes in Egypt, Arab Rep. in 1999 and the Number of enrolments of both sexes in Turkey in 2000?
Offer a terse response. 2.01e+06. What is the difference between the Number of enrolments of both sexes of Canada in 1999 and the Number of enrolments of both sexes of Costa Rica in 2009?
Your answer should be very brief. 2.11e+06. What is the difference between the Number of enrolments of both sexes in Canada in 1999 and the Number of enrolments of both sexes in Egypt, Arab Rep. in 2009?
Your answer should be compact. -4.15e+06. What is the difference between the Number of enrolments of both sexes of Canada in 1999 and the Number of enrolments of both sexes of Turkey in 2009?
Offer a very short reply. -4.59e+06. What is the difference between the Number of enrolments of both sexes in Costa Rica in 1999 and the Number of enrolments of both sexes in Egypt, Arab Rep. in 2009?
Your answer should be very brief. -6.41e+06. What is the difference between the Number of enrolments of both sexes of Costa Rica in 1999 and the Number of enrolments of both sexes of Turkey in 2009?
Ensure brevity in your answer.  -6.85e+06. What is the difference between the Number of enrolments of both sexes in Egypt, Arab Rep. in 1999 and the Number of enrolments of both sexes in Turkey in 2009?
Make the answer very short. 5.70e+05. What is the difference between the Number of enrolments of both sexes in Canada in 1999 and the Number of enrolments of both sexes in Costa Rica in 2010?
Provide a succinct answer. 2.10e+06. What is the difference between the Number of enrolments of both sexes in Canada in 1999 and the Number of enrolments of both sexes in Egypt, Arab Rep. in 2010?
Keep it short and to the point. -4.33e+06. What is the difference between the Number of enrolments of both sexes in Canada in 1999 and the Number of enrolments of both sexes in Turkey in 2010?
Keep it short and to the point. -5.02e+06. What is the difference between the Number of enrolments of both sexes of Costa Rica in 1999 and the Number of enrolments of both sexes of Egypt, Arab Rep. in 2010?
Give a very brief answer. -6.59e+06. What is the difference between the Number of enrolments of both sexes in Costa Rica in 1999 and the Number of enrolments of both sexes in Turkey in 2010?
Your answer should be compact. -7.28e+06. What is the difference between the Number of enrolments of both sexes in Egypt, Arab Rep. in 1999 and the Number of enrolments of both sexes in Turkey in 2010?
Your answer should be very brief. 1.40e+05. What is the difference between the Number of enrolments of both sexes in Canada in 2000 and the Number of enrolments of both sexes in Costa Rica in 2009?
Your answer should be very brief. 2.11e+06. What is the difference between the Number of enrolments of both sexes in Canada in 2000 and the Number of enrolments of both sexes in Egypt, Arab Rep. in 2009?
Keep it short and to the point. -4.15e+06. What is the difference between the Number of enrolments of both sexes of Canada in 2000 and the Number of enrolments of both sexes of Turkey in 2009?
Your answer should be compact. -4.58e+06. What is the difference between the Number of enrolments of both sexes in Costa Rica in 2000 and the Number of enrolments of both sexes in Egypt, Arab Rep. in 2009?
Offer a very short reply. -6.41e+06. What is the difference between the Number of enrolments of both sexes in Costa Rica in 2000 and the Number of enrolments of both sexes in Turkey in 2009?
Provide a succinct answer. -6.85e+06. What is the difference between the Number of enrolments of both sexes in Egypt, Arab Rep. in 2000 and the Number of enrolments of both sexes in Turkey in 2009?
Keep it short and to the point. 9.27e+05. What is the difference between the Number of enrolments of both sexes in Canada in 2000 and the Number of enrolments of both sexes in Costa Rica in 2010?
Your answer should be very brief. 2.11e+06. What is the difference between the Number of enrolments of both sexes in Canada in 2000 and the Number of enrolments of both sexes in Egypt, Arab Rep. in 2010?
Your response must be concise. -4.33e+06. What is the difference between the Number of enrolments of both sexes in Canada in 2000 and the Number of enrolments of both sexes in Turkey in 2010?
Keep it short and to the point. -5.01e+06. What is the difference between the Number of enrolments of both sexes of Costa Rica in 2000 and the Number of enrolments of both sexes of Egypt, Arab Rep. in 2010?
Your answer should be very brief. -6.59e+06. What is the difference between the Number of enrolments of both sexes of Costa Rica in 2000 and the Number of enrolments of both sexes of Turkey in 2010?
Your answer should be compact. -7.27e+06. What is the difference between the Number of enrolments of both sexes in Egypt, Arab Rep. in 2000 and the Number of enrolments of both sexes in Turkey in 2010?
Offer a terse response. 4.98e+05. What is the difference between the Number of enrolments of both sexes in Canada in 2009 and the Number of enrolments of both sexes in Costa Rica in 2010?
Provide a short and direct response. 2.24e+06. What is the difference between the Number of enrolments of both sexes of Canada in 2009 and the Number of enrolments of both sexes of Egypt, Arab Rep. in 2010?
Offer a terse response. -4.19e+06. What is the difference between the Number of enrolments of both sexes of Canada in 2009 and the Number of enrolments of both sexes of Turkey in 2010?
Ensure brevity in your answer.  -4.87e+06. What is the difference between the Number of enrolments of both sexes in Costa Rica in 2009 and the Number of enrolments of both sexes in Egypt, Arab Rep. in 2010?
Provide a succinct answer. -6.44e+06. What is the difference between the Number of enrolments of both sexes of Costa Rica in 2009 and the Number of enrolments of both sexes of Turkey in 2010?
Your answer should be very brief. -7.13e+06. What is the difference between the Number of enrolments of both sexes of Egypt, Arab Rep. in 2009 and the Number of enrolments of both sexes of Turkey in 2010?
Keep it short and to the point. -8.65e+05. What is the average Number of enrolments of both sexes in Canada per year?
Provide a short and direct response. 2.50e+06. What is the average Number of enrolments of both sexes in Costa Rica per year?
Your answer should be very brief. 2.49e+05. What is the average Number of enrolments of both sexes in Egypt, Arab Rep. per year?
Offer a terse response. 6.54e+06. What is the average Number of enrolments of both sexes of Turkey per year?
Ensure brevity in your answer.  5.41e+06. In the year 1992, what is the difference between the Number of enrolments of both sexes in Canada and Number of enrolments of both sexes in Costa Rica?
Make the answer very short. 2.19e+06. In the year 1992, what is the difference between the Number of enrolments of both sexes in Canada and Number of enrolments of both sexes in Egypt, Arab Rep.?
Offer a terse response. -2.95e+06. In the year 1992, what is the difference between the Number of enrolments of both sexes of Canada and Number of enrolments of both sexes of Turkey?
Give a very brief answer. -1.65e+06. In the year 1992, what is the difference between the Number of enrolments of both sexes in Costa Rica and Number of enrolments of both sexes in Egypt, Arab Rep.?
Ensure brevity in your answer.  -5.13e+06. In the year 1992, what is the difference between the Number of enrolments of both sexes of Costa Rica and Number of enrolments of both sexes of Turkey?
Make the answer very short. -3.84e+06. In the year 1992, what is the difference between the Number of enrolments of both sexes of Egypt, Arab Rep. and Number of enrolments of both sexes of Turkey?
Your response must be concise. 1.30e+06. In the year 1993, what is the difference between the Number of enrolments of both sexes in Canada and Number of enrolments of both sexes in Costa Rica?
Ensure brevity in your answer.  2.24e+06. In the year 1993, what is the difference between the Number of enrolments of both sexes in Canada and Number of enrolments of both sexes in Egypt, Arab Rep.?
Your response must be concise. -3.11e+06. In the year 1993, what is the difference between the Number of enrolments of both sexes in Canada and Number of enrolments of both sexes in Turkey?
Your answer should be compact. -1.90e+06. In the year 1993, what is the difference between the Number of enrolments of both sexes in Costa Rica and Number of enrolments of both sexes in Egypt, Arab Rep.?
Your response must be concise. -5.35e+06. In the year 1993, what is the difference between the Number of enrolments of both sexes in Costa Rica and Number of enrolments of both sexes in Turkey?
Your response must be concise. -4.14e+06. In the year 1993, what is the difference between the Number of enrolments of both sexes of Egypt, Arab Rep. and Number of enrolments of both sexes of Turkey?
Make the answer very short. 1.22e+06. In the year 1994, what is the difference between the Number of enrolments of both sexes in Canada and Number of enrolments of both sexes in Costa Rica?
Your answer should be very brief. 2.29e+06. In the year 1994, what is the difference between the Number of enrolments of both sexes of Canada and Number of enrolments of both sexes of Egypt, Arab Rep.?
Give a very brief answer. -3.68e+06. In the year 1994, what is the difference between the Number of enrolments of both sexes in Canada and Number of enrolments of both sexes in Turkey?
Your response must be concise. -2.02e+06. In the year 1994, what is the difference between the Number of enrolments of both sexes of Costa Rica and Number of enrolments of both sexes of Egypt, Arab Rep.?
Provide a short and direct response. -5.96e+06. In the year 1994, what is the difference between the Number of enrolments of both sexes of Costa Rica and Number of enrolments of both sexes of Turkey?
Give a very brief answer. -4.31e+06. In the year 1994, what is the difference between the Number of enrolments of both sexes of Egypt, Arab Rep. and Number of enrolments of both sexes of Turkey?
Your answer should be very brief. 1.66e+06. In the year 1995, what is the difference between the Number of enrolments of both sexes of Canada and Number of enrolments of both sexes of Costa Rica?
Offer a terse response. 2.29e+06. In the year 1995, what is the difference between the Number of enrolments of both sexes in Canada and Number of enrolments of both sexes in Egypt, Arab Rep.?
Offer a very short reply. -3.68e+06. In the year 1995, what is the difference between the Number of enrolments of both sexes in Canada and Number of enrolments of both sexes in Turkey?
Provide a short and direct response. -2.26e+06. In the year 1995, what is the difference between the Number of enrolments of both sexes in Costa Rica and Number of enrolments of both sexes in Egypt, Arab Rep.?
Provide a succinct answer. -5.97e+06. In the year 1995, what is the difference between the Number of enrolments of both sexes in Costa Rica and Number of enrolments of both sexes in Turkey?
Your answer should be compact. -4.55e+06. In the year 1995, what is the difference between the Number of enrolments of both sexes in Egypt, Arab Rep. and Number of enrolments of both sexes in Turkey?
Provide a short and direct response. 1.42e+06. In the year 1999, what is the difference between the Number of enrolments of both sexes of Canada and Number of enrolments of both sexes of Costa Rica?
Give a very brief answer. 2.26e+06. In the year 1999, what is the difference between the Number of enrolments of both sexes of Canada and Number of enrolments of both sexes of Egypt, Arab Rep.?
Keep it short and to the point. -5.16e+06. In the year 1999, what is the difference between the Number of enrolments of both sexes in Canada and Number of enrolments of both sexes in Turkey?
Make the answer very short. -3.01e+06. In the year 1999, what is the difference between the Number of enrolments of both sexes in Costa Rica and Number of enrolments of both sexes in Egypt, Arab Rep.?
Your response must be concise. -7.42e+06. In the year 1999, what is the difference between the Number of enrolments of both sexes of Costa Rica and Number of enrolments of both sexes of Turkey?
Your answer should be compact. -5.27e+06. In the year 1999, what is the difference between the Number of enrolments of both sexes of Egypt, Arab Rep. and Number of enrolments of both sexes of Turkey?
Your response must be concise. 2.15e+06. In the year 2000, what is the difference between the Number of enrolments of both sexes in Canada and Number of enrolments of both sexes in Costa Rica?
Your answer should be very brief. 2.26e+06. In the year 2000, what is the difference between the Number of enrolments of both sexes of Canada and Number of enrolments of both sexes of Egypt, Arab Rep.?
Your answer should be very brief. -5.51e+06. In the year 2000, what is the difference between the Number of enrolments of both sexes of Canada and Number of enrolments of both sexes of Turkey?
Your answer should be compact. -3.14e+06. In the year 2000, what is the difference between the Number of enrolments of both sexes in Costa Rica and Number of enrolments of both sexes in Egypt, Arab Rep.?
Your answer should be very brief. -7.77e+06. In the year 2000, what is the difference between the Number of enrolments of both sexes in Costa Rica and Number of enrolments of both sexes in Turkey?
Provide a succinct answer. -5.40e+06. In the year 2000, what is the difference between the Number of enrolments of both sexes in Egypt, Arab Rep. and Number of enrolments of both sexes in Turkey?
Make the answer very short. 2.37e+06. In the year 2009, what is the difference between the Number of enrolments of both sexes in Canada and Number of enrolments of both sexes in Costa Rica?
Give a very brief answer. 2.25e+06. In the year 2009, what is the difference between the Number of enrolments of both sexes of Canada and Number of enrolments of both sexes of Egypt, Arab Rep.?
Ensure brevity in your answer.  -4.01e+06. In the year 2009, what is the difference between the Number of enrolments of both sexes of Canada and Number of enrolments of both sexes of Turkey?
Provide a succinct answer. -4.44e+06. In the year 2009, what is the difference between the Number of enrolments of both sexes of Costa Rica and Number of enrolments of both sexes of Egypt, Arab Rep.?
Your answer should be compact. -6.26e+06. In the year 2009, what is the difference between the Number of enrolments of both sexes of Costa Rica and Number of enrolments of both sexes of Turkey?
Provide a short and direct response. -6.70e+06. In the year 2009, what is the difference between the Number of enrolments of both sexes in Egypt, Arab Rep. and Number of enrolments of both sexes in Turkey?
Offer a very short reply. -4.35e+05. In the year 2010, what is the difference between the Number of enrolments of both sexes in Canada and Number of enrolments of both sexes in Costa Rica?
Give a very brief answer. 2.20e+06. In the year 2010, what is the difference between the Number of enrolments of both sexes in Canada and Number of enrolments of both sexes in Egypt, Arab Rep.?
Ensure brevity in your answer.  -4.23e+06. In the year 2010, what is the difference between the Number of enrolments of both sexes of Canada and Number of enrolments of both sexes of Turkey?
Offer a terse response. -4.92e+06. In the year 2010, what is the difference between the Number of enrolments of both sexes of Costa Rica and Number of enrolments of both sexes of Egypt, Arab Rep.?
Keep it short and to the point. -6.43e+06. In the year 2010, what is the difference between the Number of enrolments of both sexes in Costa Rica and Number of enrolments of both sexes in Turkey?
Ensure brevity in your answer.  -7.12e+06. In the year 2010, what is the difference between the Number of enrolments of both sexes of Egypt, Arab Rep. and Number of enrolments of both sexes of Turkey?
Your response must be concise. -6.85e+05. What is the ratio of the Number of enrolments of both sexes in Canada in 1992 to that in 1993?
Your answer should be very brief. 0.97. What is the ratio of the Number of enrolments of both sexes of Costa Rica in 1992 to that in 1993?
Keep it short and to the point. 0.95. What is the ratio of the Number of enrolments of both sexes in Egypt, Arab Rep. in 1992 to that in 1993?
Make the answer very short. 0.96. What is the ratio of the Number of enrolments of both sexes of Turkey in 1992 to that in 1993?
Provide a succinct answer. 0.93. What is the ratio of the Number of enrolments of both sexes of Costa Rica in 1992 to that in 1994?
Give a very brief answer. 0.89. What is the ratio of the Number of enrolments of both sexes of Egypt, Arab Rep. in 1992 to that in 1994?
Ensure brevity in your answer.  0.86. What is the ratio of the Number of enrolments of both sexes of Turkey in 1992 to that in 1994?
Offer a very short reply. 0.89. What is the ratio of the Number of enrolments of both sexes in Canada in 1992 to that in 1995?
Offer a very short reply. 0.95. What is the ratio of the Number of enrolments of both sexes of Costa Rica in 1992 to that in 1995?
Keep it short and to the point. 0.84. What is the ratio of the Number of enrolments of both sexes of Egypt, Arab Rep. in 1992 to that in 1995?
Make the answer very short. 0.86. What is the ratio of the Number of enrolments of both sexes of Turkey in 1992 to that in 1995?
Your answer should be very brief. 0.84. What is the ratio of the Number of enrolments of both sexes of Canada in 1992 to that in 1999?
Your response must be concise. 0.93. What is the ratio of the Number of enrolments of both sexes of Costa Rica in 1992 to that in 1999?
Provide a short and direct response. 0.6. What is the ratio of the Number of enrolments of both sexes of Egypt, Arab Rep. in 1992 to that in 1999?
Your answer should be compact. 0.69. What is the ratio of the Number of enrolments of both sexes of Turkey in 1992 to that in 1999?
Your response must be concise. 0.72. What is the ratio of the Number of enrolments of both sexes in Canada in 1992 to that in 2000?
Your answer should be very brief. 0.93. What is the ratio of the Number of enrolments of both sexes in Costa Rica in 1992 to that in 2000?
Give a very brief answer. 0.59. What is the ratio of the Number of enrolments of both sexes of Egypt, Arab Rep. in 1992 to that in 2000?
Keep it short and to the point. 0.66. What is the ratio of the Number of enrolments of both sexes of Turkey in 1992 to that in 2000?
Offer a terse response. 0.7. What is the ratio of the Number of enrolments of both sexes of Canada in 1992 to that in 2009?
Provide a succinct answer. 0.88. What is the ratio of the Number of enrolments of both sexes of Costa Rica in 1992 to that in 2009?
Ensure brevity in your answer.  0.37. What is the ratio of the Number of enrolments of both sexes of Egypt, Arab Rep. in 1992 to that in 2009?
Make the answer very short. 0.79. What is the ratio of the Number of enrolments of both sexes in Turkey in 1992 to that in 2009?
Keep it short and to the point. 0.56. What is the ratio of the Number of enrolments of both sexes in Canada in 1992 to that in 2010?
Your answer should be compact. 0.9. What is the ratio of the Number of enrolments of both sexes of Costa Rica in 1992 to that in 2010?
Your response must be concise. 0.37. What is the ratio of the Number of enrolments of both sexes in Egypt, Arab Rep. in 1992 to that in 2010?
Ensure brevity in your answer.  0.77. What is the ratio of the Number of enrolments of both sexes of Turkey in 1992 to that in 2010?
Give a very brief answer. 0.53. What is the ratio of the Number of enrolments of both sexes in Canada in 1993 to that in 1994?
Provide a succinct answer. 0.98. What is the ratio of the Number of enrolments of both sexes of Costa Rica in 1993 to that in 1994?
Your response must be concise. 0.94. What is the ratio of the Number of enrolments of both sexes of Egypt, Arab Rep. in 1993 to that in 1994?
Keep it short and to the point. 0.9. What is the ratio of the Number of enrolments of both sexes in Turkey in 1993 to that in 1994?
Offer a terse response. 0.96. What is the ratio of the Number of enrolments of both sexes of Canada in 1993 to that in 1995?
Give a very brief answer. 0.97. What is the ratio of the Number of enrolments of both sexes in Costa Rica in 1993 to that in 1995?
Offer a very short reply. 0.89. What is the ratio of the Number of enrolments of both sexes of Egypt, Arab Rep. in 1993 to that in 1995?
Give a very brief answer. 0.9. What is the ratio of the Number of enrolments of both sexes in Turkey in 1993 to that in 1995?
Your answer should be compact. 0.91. What is the ratio of the Number of enrolments of both sexes in Canada in 1993 to that in 1999?
Your response must be concise. 0.96. What is the ratio of the Number of enrolments of both sexes of Costa Rica in 1993 to that in 1999?
Offer a very short reply. 0.63. What is the ratio of the Number of enrolments of both sexes of Egypt, Arab Rep. in 1993 to that in 1999?
Your response must be concise. 0.72. What is the ratio of the Number of enrolments of both sexes in Turkey in 1993 to that in 1999?
Give a very brief answer. 0.78. What is the ratio of the Number of enrolments of both sexes in Canada in 1993 to that in 2000?
Provide a succinct answer. 0.95. What is the ratio of the Number of enrolments of both sexes of Costa Rica in 1993 to that in 2000?
Offer a terse response. 0.63. What is the ratio of the Number of enrolments of both sexes in Egypt, Arab Rep. in 1993 to that in 2000?
Provide a succinct answer. 0.69. What is the ratio of the Number of enrolments of both sexes of Turkey in 1993 to that in 2000?
Provide a succinct answer. 0.76. What is the ratio of the Number of enrolments of both sexes in Canada in 1993 to that in 2009?
Your response must be concise. 0.9. What is the ratio of the Number of enrolments of both sexes of Costa Rica in 1993 to that in 2009?
Your answer should be very brief. 0.4. What is the ratio of the Number of enrolments of both sexes in Egypt, Arab Rep. in 1993 to that in 2009?
Make the answer very short. 0.83. What is the ratio of the Number of enrolments of both sexes of Turkey in 1993 to that in 2009?
Your response must be concise. 0.61. What is the ratio of the Number of enrolments of both sexes of Canada in 1993 to that in 2010?
Make the answer very short. 0.92. What is the ratio of the Number of enrolments of both sexes in Costa Rica in 1993 to that in 2010?
Give a very brief answer. 0.39. What is the ratio of the Number of enrolments of both sexes in Egypt, Arab Rep. in 1993 to that in 2010?
Your answer should be compact. 0.81. What is the ratio of the Number of enrolments of both sexes of Turkey in 1993 to that in 2010?
Provide a succinct answer. 0.57. What is the ratio of the Number of enrolments of both sexes of Canada in 1994 to that in 1995?
Your answer should be very brief. 0.99. What is the ratio of the Number of enrolments of both sexes in Costa Rica in 1994 to that in 1995?
Your answer should be compact. 0.95. What is the ratio of the Number of enrolments of both sexes in Egypt, Arab Rep. in 1994 to that in 1995?
Offer a very short reply. 1. What is the ratio of the Number of enrolments of both sexes in Turkey in 1994 to that in 1995?
Provide a succinct answer. 0.95. What is the ratio of the Number of enrolments of both sexes in Canada in 1994 to that in 1999?
Keep it short and to the point. 0.98. What is the ratio of the Number of enrolments of both sexes of Costa Rica in 1994 to that in 1999?
Make the answer very short. 0.67. What is the ratio of the Number of enrolments of both sexes in Egypt, Arab Rep. in 1994 to that in 1999?
Offer a terse response. 0.8. What is the ratio of the Number of enrolments of both sexes in Turkey in 1994 to that in 1999?
Your answer should be compact. 0.81. What is the ratio of the Number of enrolments of both sexes in Canada in 1994 to that in 2000?
Offer a very short reply. 0.97. What is the ratio of the Number of enrolments of both sexes of Costa Rica in 1994 to that in 2000?
Ensure brevity in your answer.  0.66. What is the ratio of the Number of enrolments of both sexes of Egypt, Arab Rep. in 1994 to that in 2000?
Offer a very short reply. 0.76. What is the ratio of the Number of enrolments of both sexes in Turkey in 1994 to that in 2000?
Your answer should be very brief. 0.79. What is the ratio of the Number of enrolments of both sexes of Canada in 1994 to that in 2009?
Ensure brevity in your answer.  0.92. What is the ratio of the Number of enrolments of both sexes in Costa Rica in 1994 to that in 2009?
Your answer should be compact. 0.42. What is the ratio of the Number of enrolments of both sexes of Egypt, Arab Rep. in 1994 to that in 2009?
Provide a short and direct response. 0.92. What is the ratio of the Number of enrolments of both sexes in Turkey in 1994 to that in 2009?
Make the answer very short. 0.63. What is the ratio of the Number of enrolments of both sexes of Canada in 1994 to that in 2010?
Offer a very short reply. 0.94. What is the ratio of the Number of enrolments of both sexes of Costa Rica in 1994 to that in 2010?
Provide a succinct answer. 0.41. What is the ratio of the Number of enrolments of both sexes in Egypt, Arab Rep. in 1994 to that in 2010?
Make the answer very short. 0.9. What is the ratio of the Number of enrolments of both sexes of Turkey in 1994 to that in 2010?
Ensure brevity in your answer.  0.59. What is the ratio of the Number of enrolments of both sexes of Canada in 1995 to that in 1999?
Your response must be concise. 0.98. What is the ratio of the Number of enrolments of both sexes in Costa Rica in 1995 to that in 1999?
Give a very brief answer. 0.7. What is the ratio of the Number of enrolments of both sexes in Egypt, Arab Rep. in 1995 to that in 1999?
Make the answer very short. 0.8. What is the ratio of the Number of enrolments of both sexes of Turkey in 1995 to that in 1999?
Provide a short and direct response. 0.86. What is the ratio of the Number of enrolments of both sexes of Canada in 1995 to that in 2000?
Keep it short and to the point. 0.98. What is the ratio of the Number of enrolments of both sexes of Costa Rica in 1995 to that in 2000?
Your response must be concise. 0.7. What is the ratio of the Number of enrolments of both sexes of Egypt, Arab Rep. in 1995 to that in 2000?
Make the answer very short. 0.77. What is the ratio of the Number of enrolments of both sexes of Turkey in 1995 to that in 2000?
Give a very brief answer. 0.84. What is the ratio of the Number of enrolments of both sexes of Canada in 1995 to that in 2009?
Give a very brief answer. 0.93. What is the ratio of the Number of enrolments of both sexes in Costa Rica in 1995 to that in 2009?
Ensure brevity in your answer.  0.44. What is the ratio of the Number of enrolments of both sexes in Egypt, Arab Rep. in 1995 to that in 2009?
Offer a terse response. 0.92. What is the ratio of the Number of enrolments of both sexes in Turkey in 1995 to that in 2009?
Your response must be concise. 0.67. What is the ratio of the Number of enrolments of both sexes of Canada in 1995 to that in 2010?
Offer a very short reply. 0.95. What is the ratio of the Number of enrolments of both sexes of Costa Rica in 1995 to that in 2010?
Keep it short and to the point. 0.43. What is the ratio of the Number of enrolments of both sexes in Egypt, Arab Rep. in 1995 to that in 2010?
Give a very brief answer. 0.9. What is the ratio of the Number of enrolments of both sexes of Turkey in 1995 to that in 2010?
Offer a terse response. 0.63. What is the ratio of the Number of enrolments of both sexes in Costa Rica in 1999 to that in 2000?
Provide a succinct answer. 1. What is the ratio of the Number of enrolments of both sexes in Egypt, Arab Rep. in 1999 to that in 2000?
Your response must be concise. 0.96. What is the ratio of the Number of enrolments of both sexes of Turkey in 1999 to that in 2000?
Provide a short and direct response. 0.98. What is the ratio of the Number of enrolments of both sexes in Canada in 1999 to that in 2009?
Ensure brevity in your answer.  0.94. What is the ratio of the Number of enrolments of both sexes in Costa Rica in 1999 to that in 2009?
Make the answer very short. 0.63. What is the ratio of the Number of enrolments of both sexes of Egypt, Arab Rep. in 1999 to that in 2009?
Your answer should be very brief. 1.15. What is the ratio of the Number of enrolments of both sexes in Turkey in 1999 to that in 2009?
Your response must be concise. 0.78. What is the ratio of the Number of enrolments of both sexes in Canada in 1999 to that in 2010?
Your response must be concise. 0.96. What is the ratio of the Number of enrolments of both sexes of Costa Rica in 1999 to that in 2010?
Offer a terse response. 0.62. What is the ratio of the Number of enrolments of both sexes of Egypt, Arab Rep. in 1999 to that in 2010?
Provide a succinct answer. 1.12. What is the ratio of the Number of enrolments of both sexes in Turkey in 1999 to that in 2010?
Keep it short and to the point. 0.73. What is the ratio of the Number of enrolments of both sexes of Canada in 2000 to that in 2009?
Offer a terse response. 0.95. What is the ratio of the Number of enrolments of both sexes in Costa Rica in 2000 to that in 2009?
Ensure brevity in your answer.  0.63. What is the ratio of the Number of enrolments of both sexes in Egypt, Arab Rep. in 2000 to that in 2009?
Offer a very short reply. 1.2. What is the ratio of the Number of enrolments of both sexes in Turkey in 2000 to that in 2009?
Your answer should be compact. 0.8. What is the ratio of the Number of enrolments of both sexes in Canada in 2000 to that in 2010?
Give a very brief answer. 0.96. What is the ratio of the Number of enrolments of both sexes in Costa Rica in 2000 to that in 2010?
Your answer should be very brief. 0.62. What is the ratio of the Number of enrolments of both sexes of Egypt, Arab Rep. in 2000 to that in 2010?
Give a very brief answer. 1.17. What is the ratio of the Number of enrolments of both sexes of Turkey in 2000 to that in 2010?
Ensure brevity in your answer.  0.75. What is the ratio of the Number of enrolments of both sexes of Canada in 2009 to that in 2010?
Ensure brevity in your answer.  1.02. What is the ratio of the Number of enrolments of both sexes in Costa Rica in 2009 to that in 2010?
Ensure brevity in your answer.  0.98. What is the ratio of the Number of enrolments of both sexes of Egypt, Arab Rep. in 2009 to that in 2010?
Your response must be concise. 0.97. What is the ratio of the Number of enrolments of both sexes in Turkey in 2009 to that in 2010?
Offer a terse response. 0.94. What is the difference between the highest and the second highest Number of enrolments of both sexes in Canada?
Offer a terse response. 4.63e+04. What is the difference between the highest and the second highest Number of enrolments of both sexes in Costa Rica?
Ensure brevity in your answer.  8102. What is the difference between the highest and the second highest Number of enrolments of both sexes of Egypt, Arab Rep.?
Your response must be concise. 3.57e+05. What is the difference between the highest and the second highest Number of enrolments of both sexes in Turkey?
Make the answer very short. 4.30e+05. What is the difference between the highest and the lowest Number of enrolments of both sexes in Canada?
Provide a succinct answer. 3.20e+05. What is the difference between the highest and the lowest Number of enrolments of both sexes of Costa Rica?
Ensure brevity in your answer.  2.62e+05. What is the difference between the highest and the lowest Number of enrolments of both sexes in Egypt, Arab Rep.?
Offer a very short reply. 2.74e+06. What is the difference between the highest and the lowest Number of enrolments of both sexes in Turkey?
Your answer should be very brief. 3.54e+06. 